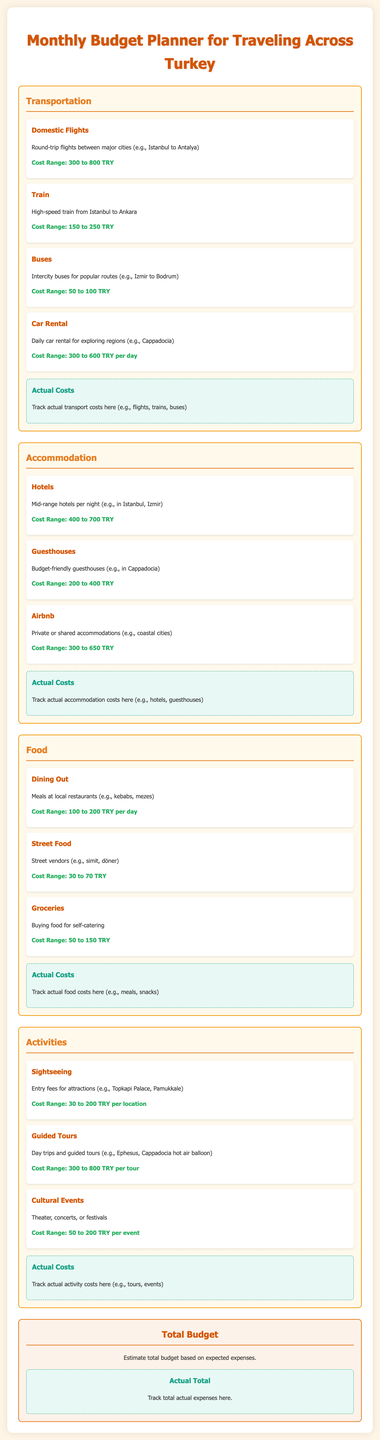What is the cost range for domestic flights? The cost range for domestic flights is specified in the transportation section of the document.
Answer: 300 to 800 TRY What type of accommodation has a cost range of 200 to 400 TRY? This question focuses on a specific type of accommodation within the document.
Answer: Guesthouses What is the daily cost range for dining out? This question references the food section of the document that lists daily expenses for meals.
Answer: 100 to 200 TRY How much can you expect to spend on street food? This question inquires about a specific expense related to food mentioned in the document.
Answer: 30 to 70 TRY What is the cost range for guided tours? This question asks about a specific type of activity and its associated costs as listed in the activities section.
Answer: 300 to 800 TRY Where can you track your actual food costs? This question pertains to the document's structure, asking about the tracking area specific to food.
Answer: Actual Costs section Which section contains information about transportation? This question refers to the categorization of expenses in the document.
Answer: Transportation What is the maximum expected cost for staying in mid-range hotels? The answer to this question can be found under the accommodation costs, which list ranges.
Answer: 700 TRY 